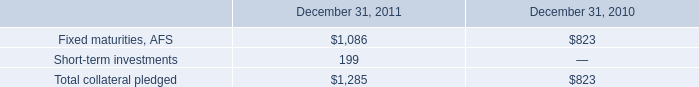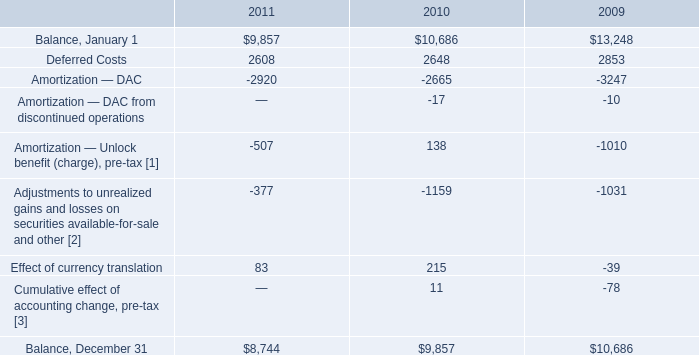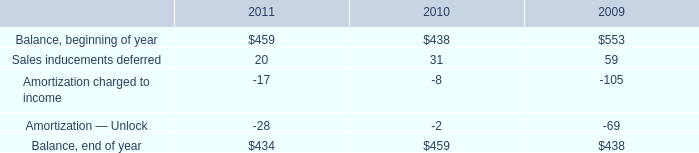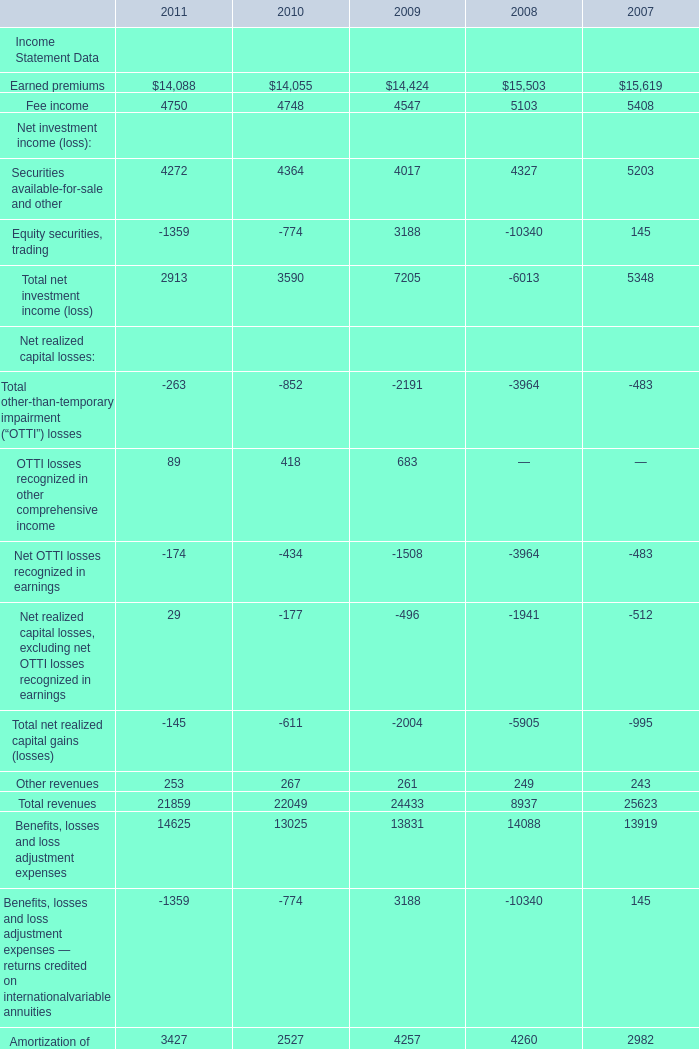what was the ratio of the collateral pledged in 2011 to 2010 
Computations: (1.1 / 790)
Answer: 0.00139. 